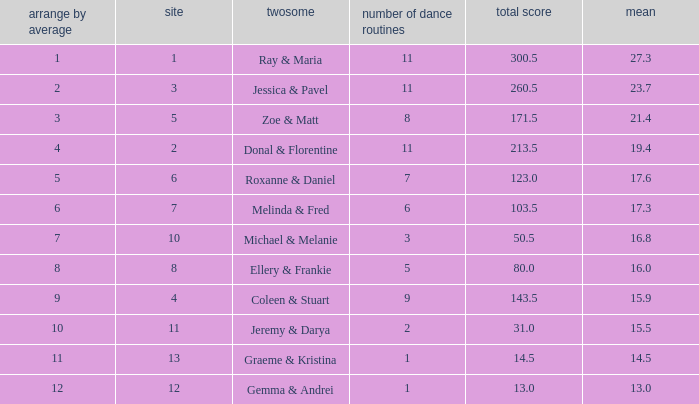What place would you be in if your rank by average is less than 2.0? 1.0. 